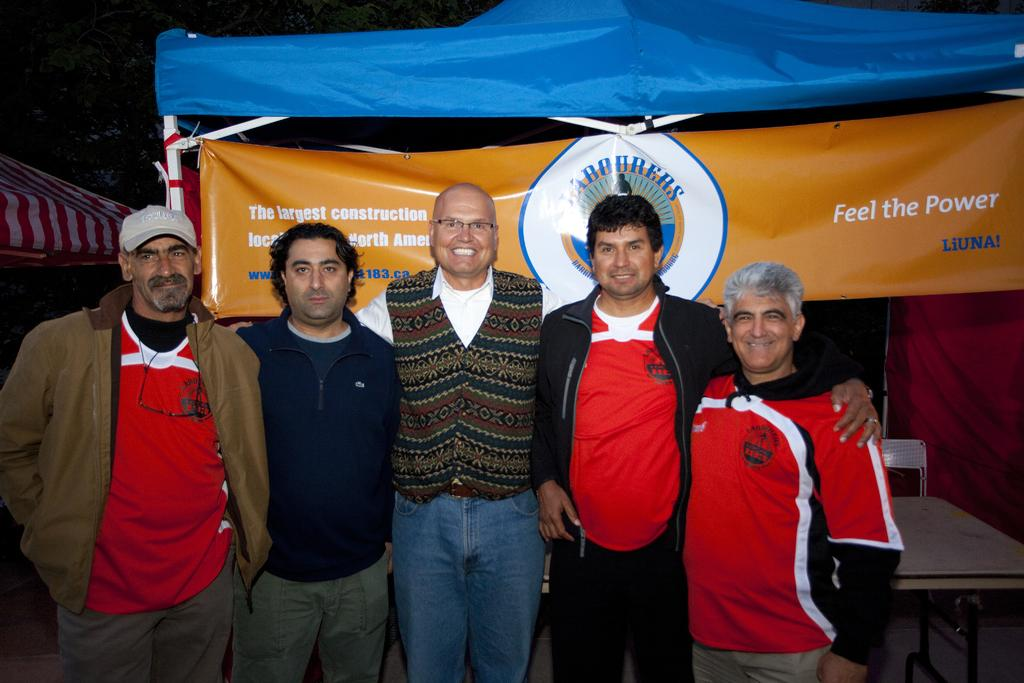How many people are on the stage in the image? There are five persons standing on the stage. What can be seen in the background of the image? There is a table, a banner, tents, and trees in the background. What might be the time of day when the image was taken? The image might have been taken during night, as there are no visible light sources other than the stage. What type of maid can be seen wearing a scarf in the image? There is no maid or scarf present in the image. What is the dust level like in the image? There is no visible dust in the image. 